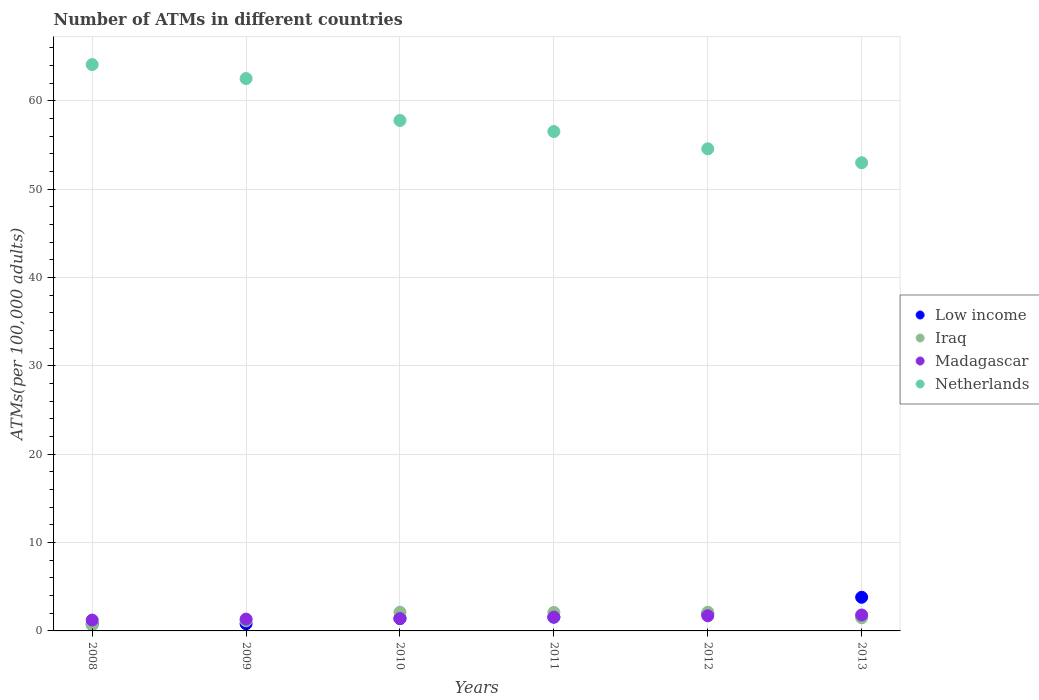Is the number of dotlines equal to the number of legend labels?
Provide a succinct answer. Yes. What is the number of ATMs in Iraq in 2011?
Offer a terse response. 2.09. Across all years, what is the maximum number of ATMs in Iraq?
Give a very brief answer. 2.12. Across all years, what is the minimum number of ATMs in Madagascar?
Your response must be concise. 1.23. In which year was the number of ATMs in Netherlands maximum?
Provide a short and direct response. 2008. In which year was the number of ATMs in Low income minimum?
Ensure brevity in your answer.  2008. What is the total number of ATMs in Iraq in the graph?
Ensure brevity in your answer.  9.63. What is the difference between the number of ATMs in Madagascar in 2010 and that in 2012?
Provide a succinct answer. -0.31. What is the difference between the number of ATMs in Low income in 2013 and the number of ATMs in Netherlands in 2009?
Your answer should be compact. -58.71. What is the average number of ATMs in Netherlands per year?
Offer a terse response. 58.08. In the year 2008, what is the difference between the number of ATMs in Madagascar and number of ATMs in Iraq?
Make the answer very short. 0.56. What is the ratio of the number of ATMs in Madagascar in 2010 to that in 2011?
Keep it short and to the point. 0.9. Is the number of ATMs in Netherlands in 2008 less than that in 2011?
Your answer should be very brief. No. Is the difference between the number of ATMs in Madagascar in 2011 and 2012 greater than the difference between the number of ATMs in Iraq in 2011 and 2012?
Make the answer very short. No. What is the difference between the highest and the second highest number of ATMs in Madagascar?
Offer a terse response. 0.09. What is the difference between the highest and the lowest number of ATMs in Madagascar?
Provide a succinct answer. 0.57. In how many years, is the number of ATMs in Netherlands greater than the average number of ATMs in Netherlands taken over all years?
Your answer should be compact. 2. Is the sum of the number of ATMs in Iraq in 2008 and 2012 greater than the maximum number of ATMs in Low income across all years?
Provide a short and direct response. No. Is it the case that in every year, the sum of the number of ATMs in Iraq and number of ATMs in Low income  is greater than the sum of number of ATMs in Madagascar and number of ATMs in Netherlands?
Your response must be concise. No. Does the number of ATMs in Netherlands monotonically increase over the years?
Offer a terse response. No. Is the number of ATMs in Madagascar strictly less than the number of ATMs in Netherlands over the years?
Make the answer very short. Yes. What is the difference between two consecutive major ticks on the Y-axis?
Your answer should be compact. 10. Does the graph contain grids?
Your answer should be compact. Yes. Where does the legend appear in the graph?
Give a very brief answer. Center right. What is the title of the graph?
Keep it short and to the point. Number of ATMs in different countries. What is the label or title of the Y-axis?
Provide a succinct answer. ATMs(per 100,0 adults). What is the ATMs(per 100,000 adults) of Low income in 2008?
Provide a short and direct response. 0.78. What is the ATMs(per 100,000 adults) of Iraq in 2008?
Keep it short and to the point. 0.67. What is the ATMs(per 100,000 adults) in Madagascar in 2008?
Provide a short and direct response. 1.23. What is the ATMs(per 100,000 adults) in Netherlands in 2008?
Your answer should be compact. 64.1. What is the ATMs(per 100,000 adults) of Low income in 2009?
Your response must be concise. 0.81. What is the ATMs(per 100,000 adults) of Iraq in 2009?
Your response must be concise. 1.15. What is the ATMs(per 100,000 adults) of Madagascar in 2009?
Offer a very short reply. 1.34. What is the ATMs(per 100,000 adults) of Netherlands in 2009?
Keep it short and to the point. 62.52. What is the ATMs(per 100,000 adults) of Low income in 2010?
Your answer should be compact. 1.4. What is the ATMs(per 100,000 adults) in Iraq in 2010?
Give a very brief answer. 2.12. What is the ATMs(per 100,000 adults) in Madagascar in 2010?
Provide a short and direct response. 1.4. What is the ATMs(per 100,000 adults) in Netherlands in 2010?
Offer a very short reply. 57.77. What is the ATMs(per 100,000 adults) in Low income in 2011?
Your answer should be compact. 1.56. What is the ATMs(per 100,000 adults) of Iraq in 2011?
Make the answer very short. 2.09. What is the ATMs(per 100,000 adults) of Madagascar in 2011?
Ensure brevity in your answer.  1.56. What is the ATMs(per 100,000 adults) in Netherlands in 2011?
Offer a very short reply. 56.52. What is the ATMs(per 100,000 adults) in Low income in 2012?
Give a very brief answer. 1.95. What is the ATMs(per 100,000 adults) of Iraq in 2012?
Keep it short and to the point. 2.12. What is the ATMs(per 100,000 adults) of Madagascar in 2012?
Ensure brevity in your answer.  1.71. What is the ATMs(per 100,000 adults) in Netherlands in 2012?
Your response must be concise. 54.56. What is the ATMs(per 100,000 adults) in Low income in 2013?
Make the answer very short. 3.81. What is the ATMs(per 100,000 adults) of Iraq in 2013?
Provide a short and direct response. 1.49. What is the ATMs(per 100,000 adults) of Madagascar in 2013?
Give a very brief answer. 1.8. What is the ATMs(per 100,000 adults) of Netherlands in 2013?
Give a very brief answer. 52.99. Across all years, what is the maximum ATMs(per 100,000 adults) of Low income?
Make the answer very short. 3.81. Across all years, what is the maximum ATMs(per 100,000 adults) in Iraq?
Keep it short and to the point. 2.12. Across all years, what is the maximum ATMs(per 100,000 adults) of Madagascar?
Your answer should be very brief. 1.8. Across all years, what is the maximum ATMs(per 100,000 adults) of Netherlands?
Your answer should be compact. 64.1. Across all years, what is the minimum ATMs(per 100,000 adults) of Low income?
Offer a terse response. 0.78. Across all years, what is the minimum ATMs(per 100,000 adults) of Iraq?
Offer a terse response. 0.67. Across all years, what is the minimum ATMs(per 100,000 adults) of Madagascar?
Provide a short and direct response. 1.23. Across all years, what is the minimum ATMs(per 100,000 adults) in Netherlands?
Keep it short and to the point. 52.99. What is the total ATMs(per 100,000 adults) in Low income in the graph?
Offer a very short reply. 10.32. What is the total ATMs(per 100,000 adults) in Iraq in the graph?
Your answer should be very brief. 9.63. What is the total ATMs(per 100,000 adults) in Madagascar in the graph?
Your answer should be compact. 9.04. What is the total ATMs(per 100,000 adults) in Netherlands in the graph?
Make the answer very short. 348.46. What is the difference between the ATMs(per 100,000 adults) in Low income in 2008 and that in 2009?
Provide a succinct answer. -0.03. What is the difference between the ATMs(per 100,000 adults) in Iraq in 2008 and that in 2009?
Your answer should be compact. -0.48. What is the difference between the ATMs(per 100,000 adults) in Madagascar in 2008 and that in 2009?
Your response must be concise. -0.11. What is the difference between the ATMs(per 100,000 adults) in Netherlands in 2008 and that in 2009?
Provide a succinct answer. 1.58. What is the difference between the ATMs(per 100,000 adults) in Low income in 2008 and that in 2010?
Your answer should be very brief. -0.62. What is the difference between the ATMs(per 100,000 adults) in Iraq in 2008 and that in 2010?
Give a very brief answer. -1.45. What is the difference between the ATMs(per 100,000 adults) of Madagascar in 2008 and that in 2010?
Your response must be concise. -0.17. What is the difference between the ATMs(per 100,000 adults) of Netherlands in 2008 and that in 2010?
Your answer should be compact. 6.32. What is the difference between the ATMs(per 100,000 adults) in Low income in 2008 and that in 2011?
Your answer should be very brief. -0.78. What is the difference between the ATMs(per 100,000 adults) in Iraq in 2008 and that in 2011?
Your answer should be compact. -1.42. What is the difference between the ATMs(per 100,000 adults) of Madagascar in 2008 and that in 2011?
Your answer should be compact. -0.34. What is the difference between the ATMs(per 100,000 adults) of Netherlands in 2008 and that in 2011?
Your answer should be compact. 7.57. What is the difference between the ATMs(per 100,000 adults) in Low income in 2008 and that in 2012?
Offer a very short reply. -1.17. What is the difference between the ATMs(per 100,000 adults) of Iraq in 2008 and that in 2012?
Your answer should be compact. -1.45. What is the difference between the ATMs(per 100,000 adults) of Madagascar in 2008 and that in 2012?
Your answer should be very brief. -0.49. What is the difference between the ATMs(per 100,000 adults) in Netherlands in 2008 and that in 2012?
Give a very brief answer. 9.53. What is the difference between the ATMs(per 100,000 adults) in Low income in 2008 and that in 2013?
Your response must be concise. -3.03. What is the difference between the ATMs(per 100,000 adults) of Iraq in 2008 and that in 2013?
Your answer should be very brief. -0.82. What is the difference between the ATMs(per 100,000 adults) in Madagascar in 2008 and that in 2013?
Your answer should be very brief. -0.57. What is the difference between the ATMs(per 100,000 adults) of Netherlands in 2008 and that in 2013?
Your answer should be compact. 11.11. What is the difference between the ATMs(per 100,000 adults) of Low income in 2009 and that in 2010?
Offer a terse response. -0.59. What is the difference between the ATMs(per 100,000 adults) in Iraq in 2009 and that in 2010?
Offer a very short reply. -0.97. What is the difference between the ATMs(per 100,000 adults) in Madagascar in 2009 and that in 2010?
Provide a short and direct response. -0.06. What is the difference between the ATMs(per 100,000 adults) in Netherlands in 2009 and that in 2010?
Your response must be concise. 4.74. What is the difference between the ATMs(per 100,000 adults) in Low income in 2009 and that in 2011?
Make the answer very short. -0.75. What is the difference between the ATMs(per 100,000 adults) of Iraq in 2009 and that in 2011?
Offer a terse response. -0.94. What is the difference between the ATMs(per 100,000 adults) in Madagascar in 2009 and that in 2011?
Provide a succinct answer. -0.23. What is the difference between the ATMs(per 100,000 adults) of Netherlands in 2009 and that in 2011?
Provide a short and direct response. 5.99. What is the difference between the ATMs(per 100,000 adults) of Low income in 2009 and that in 2012?
Provide a short and direct response. -1.14. What is the difference between the ATMs(per 100,000 adults) in Iraq in 2009 and that in 2012?
Keep it short and to the point. -0.97. What is the difference between the ATMs(per 100,000 adults) in Madagascar in 2009 and that in 2012?
Offer a very short reply. -0.38. What is the difference between the ATMs(per 100,000 adults) in Netherlands in 2009 and that in 2012?
Ensure brevity in your answer.  7.95. What is the difference between the ATMs(per 100,000 adults) in Low income in 2009 and that in 2013?
Provide a succinct answer. -3. What is the difference between the ATMs(per 100,000 adults) in Iraq in 2009 and that in 2013?
Offer a terse response. -0.34. What is the difference between the ATMs(per 100,000 adults) in Madagascar in 2009 and that in 2013?
Provide a succinct answer. -0.47. What is the difference between the ATMs(per 100,000 adults) in Netherlands in 2009 and that in 2013?
Make the answer very short. 9.53. What is the difference between the ATMs(per 100,000 adults) of Low income in 2010 and that in 2011?
Keep it short and to the point. -0.16. What is the difference between the ATMs(per 100,000 adults) of Iraq in 2010 and that in 2011?
Your response must be concise. 0.03. What is the difference between the ATMs(per 100,000 adults) in Madagascar in 2010 and that in 2011?
Offer a very short reply. -0.16. What is the difference between the ATMs(per 100,000 adults) of Netherlands in 2010 and that in 2011?
Make the answer very short. 1.25. What is the difference between the ATMs(per 100,000 adults) of Low income in 2010 and that in 2012?
Provide a short and direct response. -0.55. What is the difference between the ATMs(per 100,000 adults) in Iraq in 2010 and that in 2012?
Make the answer very short. 0. What is the difference between the ATMs(per 100,000 adults) in Madagascar in 2010 and that in 2012?
Ensure brevity in your answer.  -0.31. What is the difference between the ATMs(per 100,000 adults) in Netherlands in 2010 and that in 2012?
Provide a succinct answer. 3.21. What is the difference between the ATMs(per 100,000 adults) of Low income in 2010 and that in 2013?
Your answer should be very brief. -2.41. What is the difference between the ATMs(per 100,000 adults) of Iraq in 2010 and that in 2013?
Provide a succinct answer. 0.63. What is the difference between the ATMs(per 100,000 adults) in Madagascar in 2010 and that in 2013?
Offer a very short reply. -0.4. What is the difference between the ATMs(per 100,000 adults) of Netherlands in 2010 and that in 2013?
Make the answer very short. 4.78. What is the difference between the ATMs(per 100,000 adults) of Low income in 2011 and that in 2012?
Keep it short and to the point. -0.39. What is the difference between the ATMs(per 100,000 adults) in Iraq in 2011 and that in 2012?
Make the answer very short. -0.03. What is the difference between the ATMs(per 100,000 adults) in Madagascar in 2011 and that in 2012?
Your answer should be compact. -0.15. What is the difference between the ATMs(per 100,000 adults) of Netherlands in 2011 and that in 2012?
Offer a very short reply. 1.96. What is the difference between the ATMs(per 100,000 adults) in Low income in 2011 and that in 2013?
Make the answer very short. -2.25. What is the difference between the ATMs(per 100,000 adults) of Iraq in 2011 and that in 2013?
Provide a succinct answer. 0.6. What is the difference between the ATMs(per 100,000 adults) of Madagascar in 2011 and that in 2013?
Offer a very short reply. -0.24. What is the difference between the ATMs(per 100,000 adults) of Netherlands in 2011 and that in 2013?
Offer a very short reply. 3.53. What is the difference between the ATMs(per 100,000 adults) of Low income in 2012 and that in 2013?
Provide a short and direct response. -1.85. What is the difference between the ATMs(per 100,000 adults) in Iraq in 2012 and that in 2013?
Provide a short and direct response. 0.63. What is the difference between the ATMs(per 100,000 adults) of Madagascar in 2012 and that in 2013?
Provide a short and direct response. -0.09. What is the difference between the ATMs(per 100,000 adults) in Netherlands in 2012 and that in 2013?
Make the answer very short. 1.58. What is the difference between the ATMs(per 100,000 adults) in Low income in 2008 and the ATMs(per 100,000 adults) in Iraq in 2009?
Give a very brief answer. -0.37. What is the difference between the ATMs(per 100,000 adults) of Low income in 2008 and the ATMs(per 100,000 adults) of Madagascar in 2009?
Offer a terse response. -0.55. What is the difference between the ATMs(per 100,000 adults) of Low income in 2008 and the ATMs(per 100,000 adults) of Netherlands in 2009?
Your response must be concise. -61.73. What is the difference between the ATMs(per 100,000 adults) of Iraq in 2008 and the ATMs(per 100,000 adults) of Madagascar in 2009?
Make the answer very short. -0.67. What is the difference between the ATMs(per 100,000 adults) in Iraq in 2008 and the ATMs(per 100,000 adults) in Netherlands in 2009?
Offer a terse response. -61.85. What is the difference between the ATMs(per 100,000 adults) of Madagascar in 2008 and the ATMs(per 100,000 adults) of Netherlands in 2009?
Provide a succinct answer. -61.29. What is the difference between the ATMs(per 100,000 adults) in Low income in 2008 and the ATMs(per 100,000 adults) in Iraq in 2010?
Offer a very short reply. -1.33. What is the difference between the ATMs(per 100,000 adults) of Low income in 2008 and the ATMs(per 100,000 adults) of Madagascar in 2010?
Ensure brevity in your answer.  -0.62. What is the difference between the ATMs(per 100,000 adults) in Low income in 2008 and the ATMs(per 100,000 adults) in Netherlands in 2010?
Provide a succinct answer. -56.99. What is the difference between the ATMs(per 100,000 adults) of Iraq in 2008 and the ATMs(per 100,000 adults) of Madagascar in 2010?
Your answer should be very brief. -0.73. What is the difference between the ATMs(per 100,000 adults) of Iraq in 2008 and the ATMs(per 100,000 adults) of Netherlands in 2010?
Keep it short and to the point. -57.1. What is the difference between the ATMs(per 100,000 adults) in Madagascar in 2008 and the ATMs(per 100,000 adults) in Netherlands in 2010?
Give a very brief answer. -56.54. What is the difference between the ATMs(per 100,000 adults) of Low income in 2008 and the ATMs(per 100,000 adults) of Iraq in 2011?
Provide a short and direct response. -1.31. What is the difference between the ATMs(per 100,000 adults) of Low income in 2008 and the ATMs(per 100,000 adults) of Madagascar in 2011?
Make the answer very short. -0.78. What is the difference between the ATMs(per 100,000 adults) of Low income in 2008 and the ATMs(per 100,000 adults) of Netherlands in 2011?
Your response must be concise. -55.74. What is the difference between the ATMs(per 100,000 adults) of Iraq in 2008 and the ATMs(per 100,000 adults) of Madagascar in 2011?
Ensure brevity in your answer.  -0.89. What is the difference between the ATMs(per 100,000 adults) in Iraq in 2008 and the ATMs(per 100,000 adults) in Netherlands in 2011?
Make the answer very short. -55.85. What is the difference between the ATMs(per 100,000 adults) in Madagascar in 2008 and the ATMs(per 100,000 adults) in Netherlands in 2011?
Offer a terse response. -55.29. What is the difference between the ATMs(per 100,000 adults) in Low income in 2008 and the ATMs(per 100,000 adults) in Iraq in 2012?
Give a very brief answer. -1.33. What is the difference between the ATMs(per 100,000 adults) of Low income in 2008 and the ATMs(per 100,000 adults) of Madagascar in 2012?
Ensure brevity in your answer.  -0.93. What is the difference between the ATMs(per 100,000 adults) in Low income in 2008 and the ATMs(per 100,000 adults) in Netherlands in 2012?
Your response must be concise. -53.78. What is the difference between the ATMs(per 100,000 adults) in Iraq in 2008 and the ATMs(per 100,000 adults) in Madagascar in 2012?
Offer a terse response. -1.05. What is the difference between the ATMs(per 100,000 adults) in Iraq in 2008 and the ATMs(per 100,000 adults) in Netherlands in 2012?
Your response must be concise. -53.89. What is the difference between the ATMs(per 100,000 adults) in Madagascar in 2008 and the ATMs(per 100,000 adults) in Netherlands in 2012?
Offer a very short reply. -53.34. What is the difference between the ATMs(per 100,000 adults) of Low income in 2008 and the ATMs(per 100,000 adults) of Iraq in 2013?
Provide a succinct answer. -0.71. What is the difference between the ATMs(per 100,000 adults) in Low income in 2008 and the ATMs(per 100,000 adults) in Madagascar in 2013?
Offer a terse response. -1.02. What is the difference between the ATMs(per 100,000 adults) in Low income in 2008 and the ATMs(per 100,000 adults) in Netherlands in 2013?
Offer a very short reply. -52.21. What is the difference between the ATMs(per 100,000 adults) of Iraq in 2008 and the ATMs(per 100,000 adults) of Madagascar in 2013?
Your response must be concise. -1.13. What is the difference between the ATMs(per 100,000 adults) of Iraq in 2008 and the ATMs(per 100,000 adults) of Netherlands in 2013?
Keep it short and to the point. -52.32. What is the difference between the ATMs(per 100,000 adults) in Madagascar in 2008 and the ATMs(per 100,000 adults) in Netherlands in 2013?
Provide a succinct answer. -51.76. What is the difference between the ATMs(per 100,000 adults) in Low income in 2009 and the ATMs(per 100,000 adults) in Iraq in 2010?
Offer a terse response. -1.31. What is the difference between the ATMs(per 100,000 adults) of Low income in 2009 and the ATMs(per 100,000 adults) of Madagascar in 2010?
Your answer should be compact. -0.59. What is the difference between the ATMs(per 100,000 adults) of Low income in 2009 and the ATMs(per 100,000 adults) of Netherlands in 2010?
Offer a terse response. -56.96. What is the difference between the ATMs(per 100,000 adults) of Iraq in 2009 and the ATMs(per 100,000 adults) of Madagascar in 2010?
Your answer should be very brief. -0.25. What is the difference between the ATMs(per 100,000 adults) in Iraq in 2009 and the ATMs(per 100,000 adults) in Netherlands in 2010?
Give a very brief answer. -56.62. What is the difference between the ATMs(per 100,000 adults) of Madagascar in 2009 and the ATMs(per 100,000 adults) of Netherlands in 2010?
Provide a succinct answer. -56.44. What is the difference between the ATMs(per 100,000 adults) of Low income in 2009 and the ATMs(per 100,000 adults) of Iraq in 2011?
Give a very brief answer. -1.28. What is the difference between the ATMs(per 100,000 adults) in Low income in 2009 and the ATMs(per 100,000 adults) in Madagascar in 2011?
Offer a very short reply. -0.75. What is the difference between the ATMs(per 100,000 adults) of Low income in 2009 and the ATMs(per 100,000 adults) of Netherlands in 2011?
Offer a terse response. -55.71. What is the difference between the ATMs(per 100,000 adults) in Iraq in 2009 and the ATMs(per 100,000 adults) in Madagascar in 2011?
Provide a succinct answer. -0.41. What is the difference between the ATMs(per 100,000 adults) in Iraq in 2009 and the ATMs(per 100,000 adults) in Netherlands in 2011?
Offer a very short reply. -55.37. What is the difference between the ATMs(per 100,000 adults) in Madagascar in 2009 and the ATMs(per 100,000 adults) in Netherlands in 2011?
Offer a very short reply. -55.19. What is the difference between the ATMs(per 100,000 adults) in Low income in 2009 and the ATMs(per 100,000 adults) in Iraq in 2012?
Provide a succinct answer. -1.31. What is the difference between the ATMs(per 100,000 adults) of Low income in 2009 and the ATMs(per 100,000 adults) of Madagascar in 2012?
Offer a terse response. -0.91. What is the difference between the ATMs(per 100,000 adults) of Low income in 2009 and the ATMs(per 100,000 adults) of Netherlands in 2012?
Your answer should be compact. -53.75. What is the difference between the ATMs(per 100,000 adults) of Iraq in 2009 and the ATMs(per 100,000 adults) of Madagascar in 2012?
Your response must be concise. -0.56. What is the difference between the ATMs(per 100,000 adults) of Iraq in 2009 and the ATMs(per 100,000 adults) of Netherlands in 2012?
Provide a succinct answer. -53.41. What is the difference between the ATMs(per 100,000 adults) of Madagascar in 2009 and the ATMs(per 100,000 adults) of Netherlands in 2012?
Make the answer very short. -53.23. What is the difference between the ATMs(per 100,000 adults) of Low income in 2009 and the ATMs(per 100,000 adults) of Iraq in 2013?
Provide a short and direct response. -0.68. What is the difference between the ATMs(per 100,000 adults) in Low income in 2009 and the ATMs(per 100,000 adults) in Madagascar in 2013?
Your answer should be compact. -0.99. What is the difference between the ATMs(per 100,000 adults) of Low income in 2009 and the ATMs(per 100,000 adults) of Netherlands in 2013?
Offer a very short reply. -52.18. What is the difference between the ATMs(per 100,000 adults) of Iraq in 2009 and the ATMs(per 100,000 adults) of Madagascar in 2013?
Provide a succinct answer. -0.65. What is the difference between the ATMs(per 100,000 adults) of Iraq in 2009 and the ATMs(per 100,000 adults) of Netherlands in 2013?
Provide a short and direct response. -51.84. What is the difference between the ATMs(per 100,000 adults) of Madagascar in 2009 and the ATMs(per 100,000 adults) of Netherlands in 2013?
Offer a very short reply. -51.65. What is the difference between the ATMs(per 100,000 adults) of Low income in 2010 and the ATMs(per 100,000 adults) of Iraq in 2011?
Make the answer very short. -0.69. What is the difference between the ATMs(per 100,000 adults) of Low income in 2010 and the ATMs(per 100,000 adults) of Madagascar in 2011?
Provide a succinct answer. -0.16. What is the difference between the ATMs(per 100,000 adults) of Low income in 2010 and the ATMs(per 100,000 adults) of Netherlands in 2011?
Give a very brief answer. -55.12. What is the difference between the ATMs(per 100,000 adults) of Iraq in 2010 and the ATMs(per 100,000 adults) of Madagascar in 2011?
Your response must be concise. 0.55. What is the difference between the ATMs(per 100,000 adults) in Iraq in 2010 and the ATMs(per 100,000 adults) in Netherlands in 2011?
Make the answer very short. -54.41. What is the difference between the ATMs(per 100,000 adults) of Madagascar in 2010 and the ATMs(per 100,000 adults) of Netherlands in 2011?
Offer a terse response. -55.12. What is the difference between the ATMs(per 100,000 adults) of Low income in 2010 and the ATMs(per 100,000 adults) of Iraq in 2012?
Provide a short and direct response. -0.71. What is the difference between the ATMs(per 100,000 adults) of Low income in 2010 and the ATMs(per 100,000 adults) of Madagascar in 2012?
Keep it short and to the point. -0.31. What is the difference between the ATMs(per 100,000 adults) of Low income in 2010 and the ATMs(per 100,000 adults) of Netherlands in 2012?
Your response must be concise. -53.16. What is the difference between the ATMs(per 100,000 adults) in Iraq in 2010 and the ATMs(per 100,000 adults) in Madagascar in 2012?
Your answer should be compact. 0.4. What is the difference between the ATMs(per 100,000 adults) in Iraq in 2010 and the ATMs(per 100,000 adults) in Netherlands in 2012?
Ensure brevity in your answer.  -52.45. What is the difference between the ATMs(per 100,000 adults) of Madagascar in 2010 and the ATMs(per 100,000 adults) of Netherlands in 2012?
Make the answer very short. -53.16. What is the difference between the ATMs(per 100,000 adults) of Low income in 2010 and the ATMs(per 100,000 adults) of Iraq in 2013?
Your answer should be compact. -0.09. What is the difference between the ATMs(per 100,000 adults) of Low income in 2010 and the ATMs(per 100,000 adults) of Madagascar in 2013?
Provide a short and direct response. -0.4. What is the difference between the ATMs(per 100,000 adults) of Low income in 2010 and the ATMs(per 100,000 adults) of Netherlands in 2013?
Make the answer very short. -51.59. What is the difference between the ATMs(per 100,000 adults) of Iraq in 2010 and the ATMs(per 100,000 adults) of Madagascar in 2013?
Your response must be concise. 0.31. What is the difference between the ATMs(per 100,000 adults) in Iraq in 2010 and the ATMs(per 100,000 adults) in Netherlands in 2013?
Provide a succinct answer. -50.87. What is the difference between the ATMs(per 100,000 adults) of Madagascar in 2010 and the ATMs(per 100,000 adults) of Netherlands in 2013?
Your response must be concise. -51.59. What is the difference between the ATMs(per 100,000 adults) of Low income in 2011 and the ATMs(per 100,000 adults) of Iraq in 2012?
Give a very brief answer. -0.55. What is the difference between the ATMs(per 100,000 adults) in Low income in 2011 and the ATMs(per 100,000 adults) in Madagascar in 2012?
Your answer should be compact. -0.15. What is the difference between the ATMs(per 100,000 adults) in Low income in 2011 and the ATMs(per 100,000 adults) in Netherlands in 2012?
Provide a succinct answer. -53. What is the difference between the ATMs(per 100,000 adults) of Iraq in 2011 and the ATMs(per 100,000 adults) of Madagascar in 2012?
Your answer should be compact. 0.37. What is the difference between the ATMs(per 100,000 adults) in Iraq in 2011 and the ATMs(per 100,000 adults) in Netherlands in 2012?
Make the answer very short. -52.48. What is the difference between the ATMs(per 100,000 adults) of Madagascar in 2011 and the ATMs(per 100,000 adults) of Netherlands in 2012?
Provide a succinct answer. -53. What is the difference between the ATMs(per 100,000 adults) of Low income in 2011 and the ATMs(per 100,000 adults) of Iraq in 2013?
Offer a very short reply. 0.08. What is the difference between the ATMs(per 100,000 adults) in Low income in 2011 and the ATMs(per 100,000 adults) in Madagascar in 2013?
Provide a short and direct response. -0.24. What is the difference between the ATMs(per 100,000 adults) of Low income in 2011 and the ATMs(per 100,000 adults) of Netherlands in 2013?
Provide a short and direct response. -51.42. What is the difference between the ATMs(per 100,000 adults) of Iraq in 2011 and the ATMs(per 100,000 adults) of Madagascar in 2013?
Your response must be concise. 0.29. What is the difference between the ATMs(per 100,000 adults) in Iraq in 2011 and the ATMs(per 100,000 adults) in Netherlands in 2013?
Your answer should be compact. -50.9. What is the difference between the ATMs(per 100,000 adults) of Madagascar in 2011 and the ATMs(per 100,000 adults) of Netherlands in 2013?
Make the answer very short. -51.42. What is the difference between the ATMs(per 100,000 adults) in Low income in 2012 and the ATMs(per 100,000 adults) in Iraq in 2013?
Make the answer very short. 0.47. What is the difference between the ATMs(per 100,000 adults) of Low income in 2012 and the ATMs(per 100,000 adults) of Madagascar in 2013?
Ensure brevity in your answer.  0.15. What is the difference between the ATMs(per 100,000 adults) in Low income in 2012 and the ATMs(per 100,000 adults) in Netherlands in 2013?
Offer a very short reply. -51.03. What is the difference between the ATMs(per 100,000 adults) in Iraq in 2012 and the ATMs(per 100,000 adults) in Madagascar in 2013?
Offer a very short reply. 0.31. What is the difference between the ATMs(per 100,000 adults) of Iraq in 2012 and the ATMs(per 100,000 adults) of Netherlands in 2013?
Keep it short and to the point. -50.87. What is the difference between the ATMs(per 100,000 adults) of Madagascar in 2012 and the ATMs(per 100,000 adults) of Netherlands in 2013?
Give a very brief answer. -51.27. What is the average ATMs(per 100,000 adults) of Low income per year?
Make the answer very short. 1.72. What is the average ATMs(per 100,000 adults) of Iraq per year?
Provide a succinct answer. 1.6. What is the average ATMs(per 100,000 adults) in Madagascar per year?
Provide a short and direct response. 1.51. What is the average ATMs(per 100,000 adults) in Netherlands per year?
Provide a succinct answer. 58.08. In the year 2008, what is the difference between the ATMs(per 100,000 adults) of Low income and ATMs(per 100,000 adults) of Iraq?
Your answer should be compact. 0.11. In the year 2008, what is the difference between the ATMs(per 100,000 adults) of Low income and ATMs(per 100,000 adults) of Madagascar?
Your answer should be very brief. -0.45. In the year 2008, what is the difference between the ATMs(per 100,000 adults) of Low income and ATMs(per 100,000 adults) of Netherlands?
Your response must be concise. -63.31. In the year 2008, what is the difference between the ATMs(per 100,000 adults) of Iraq and ATMs(per 100,000 adults) of Madagascar?
Give a very brief answer. -0.56. In the year 2008, what is the difference between the ATMs(per 100,000 adults) of Iraq and ATMs(per 100,000 adults) of Netherlands?
Make the answer very short. -63.43. In the year 2008, what is the difference between the ATMs(per 100,000 adults) in Madagascar and ATMs(per 100,000 adults) in Netherlands?
Offer a very short reply. -62.87. In the year 2009, what is the difference between the ATMs(per 100,000 adults) of Low income and ATMs(per 100,000 adults) of Iraq?
Your response must be concise. -0.34. In the year 2009, what is the difference between the ATMs(per 100,000 adults) of Low income and ATMs(per 100,000 adults) of Madagascar?
Provide a succinct answer. -0.53. In the year 2009, what is the difference between the ATMs(per 100,000 adults) in Low income and ATMs(per 100,000 adults) in Netherlands?
Provide a short and direct response. -61.71. In the year 2009, what is the difference between the ATMs(per 100,000 adults) in Iraq and ATMs(per 100,000 adults) in Madagascar?
Provide a short and direct response. -0.19. In the year 2009, what is the difference between the ATMs(per 100,000 adults) of Iraq and ATMs(per 100,000 adults) of Netherlands?
Give a very brief answer. -61.37. In the year 2009, what is the difference between the ATMs(per 100,000 adults) in Madagascar and ATMs(per 100,000 adults) in Netherlands?
Ensure brevity in your answer.  -61.18. In the year 2010, what is the difference between the ATMs(per 100,000 adults) in Low income and ATMs(per 100,000 adults) in Iraq?
Ensure brevity in your answer.  -0.71. In the year 2010, what is the difference between the ATMs(per 100,000 adults) of Low income and ATMs(per 100,000 adults) of Madagascar?
Make the answer very short. 0. In the year 2010, what is the difference between the ATMs(per 100,000 adults) of Low income and ATMs(per 100,000 adults) of Netherlands?
Make the answer very short. -56.37. In the year 2010, what is the difference between the ATMs(per 100,000 adults) of Iraq and ATMs(per 100,000 adults) of Madagascar?
Ensure brevity in your answer.  0.72. In the year 2010, what is the difference between the ATMs(per 100,000 adults) in Iraq and ATMs(per 100,000 adults) in Netherlands?
Provide a succinct answer. -55.66. In the year 2010, what is the difference between the ATMs(per 100,000 adults) in Madagascar and ATMs(per 100,000 adults) in Netherlands?
Offer a very short reply. -56.37. In the year 2011, what is the difference between the ATMs(per 100,000 adults) in Low income and ATMs(per 100,000 adults) in Iraq?
Your answer should be very brief. -0.52. In the year 2011, what is the difference between the ATMs(per 100,000 adults) of Low income and ATMs(per 100,000 adults) of Netherlands?
Your answer should be very brief. -54.96. In the year 2011, what is the difference between the ATMs(per 100,000 adults) in Iraq and ATMs(per 100,000 adults) in Madagascar?
Your answer should be very brief. 0.52. In the year 2011, what is the difference between the ATMs(per 100,000 adults) of Iraq and ATMs(per 100,000 adults) of Netherlands?
Keep it short and to the point. -54.43. In the year 2011, what is the difference between the ATMs(per 100,000 adults) in Madagascar and ATMs(per 100,000 adults) in Netherlands?
Your answer should be very brief. -54.96. In the year 2012, what is the difference between the ATMs(per 100,000 adults) of Low income and ATMs(per 100,000 adults) of Iraq?
Your answer should be compact. -0.16. In the year 2012, what is the difference between the ATMs(per 100,000 adults) in Low income and ATMs(per 100,000 adults) in Madagascar?
Keep it short and to the point. 0.24. In the year 2012, what is the difference between the ATMs(per 100,000 adults) of Low income and ATMs(per 100,000 adults) of Netherlands?
Keep it short and to the point. -52.61. In the year 2012, what is the difference between the ATMs(per 100,000 adults) in Iraq and ATMs(per 100,000 adults) in Madagascar?
Offer a very short reply. 0.4. In the year 2012, what is the difference between the ATMs(per 100,000 adults) of Iraq and ATMs(per 100,000 adults) of Netherlands?
Your response must be concise. -52.45. In the year 2012, what is the difference between the ATMs(per 100,000 adults) of Madagascar and ATMs(per 100,000 adults) of Netherlands?
Offer a very short reply. -52.85. In the year 2013, what is the difference between the ATMs(per 100,000 adults) of Low income and ATMs(per 100,000 adults) of Iraq?
Provide a succinct answer. 2.32. In the year 2013, what is the difference between the ATMs(per 100,000 adults) in Low income and ATMs(per 100,000 adults) in Madagascar?
Your answer should be compact. 2.01. In the year 2013, what is the difference between the ATMs(per 100,000 adults) in Low income and ATMs(per 100,000 adults) in Netherlands?
Your response must be concise. -49.18. In the year 2013, what is the difference between the ATMs(per 100,000 adults) in Iraq and ATMs(per 100,000 adults) in Madagascar?
Provide a succinct answer. -0.31. In the year 2013, what is the difference between the ATMs(per 100,000 adults) of Iraq and ATMs(per 100,000 adults) of Netherlands?
Offer a very short reply. -51.5. In the year 2013, what is the difference between the ATMs(per 100,000 adults) in Madagascar and ATMs(per 100,000 adults) in Netherlands?
Your answer should be compact. -51.19. What is the ratio of the ATMs(per 100,000 adults) in Low income in 2008 to that in 2009?
Your answer should be compact. 0.97. What is the ratio of the ATMs(per 100,000 adults) of Iraq in 2008 to that in 2009?
Your answer should be compact. 0.58. What is the ratio of the ATMs(per 100,000 adults) in Netherlands in 2008 to that in 2009?
Provide a short and direct response. 1.03. What is the ratio of the ATMs(per 100,000 adults) of Low income in 2008 to that in 2010?
Give a very brief answer. 0.56. What is the ratio of the ATMs(per 100,000 adults) of Iraq in 2008 to that in 2010?
Make the answer very short. 0.32. What is the ratio of the ATMs(per 100,000 adults) in Madagascar in 2008 to that in 2010?
Provide a succinct answer. 0.88. What is the ratio of the ATMs(per 100,000 adults) in Netherlands in 2008 to that in 2010?
Your answer should be very brief. 1.11. What is the ratio of the ATMs(per 100,000 adults) in Low income in 2008 to that in 2011?
Your answer should be very brief. 0.5. What is the ratio of the ATMs(per 100,000 adults) of Iraq in 2008 to that in 2011?
Provide a succinct answer. 0.32. What is the ratio of the ATMs(per 100,000 adults) of Madagascar in 2008 to that in 2011?
Your answer should be compact. 0.79. What is the ratio of the ATMs(per 100,000 adults) of Netherlands in 2008 to that in 2011?
Make the answer very short. 1.13. What is the ratio of the ATMs(per 100,000 adults) in Low income in 2008 to that in 2012?
Make the answer very short. 0.4. What is the ratio of the ATMs(per 100,000 adults) of Iraq in 2008 to that in 2012?
Give a very brief answer. 0.32. What is the ratio of the ATMs(per 100,000 adults) of Madagascar in 2008 to that in 2012?
Your answer should be very brief. 0.72. What is the ratio of the ATMs(per 100,000 adults) in Netherlands in 2008 to that in 2012?
Provide a short and direct response. 1.17. What is the ratio of the ATMs(per 100,000 adults) of Low income in 2008 to that in 2013?
Ensure brevity in your answer.  0.21. What is the ratio of the ATMs(per 100,000 adults) in Iraq in 2008 to that in 2013?
Your response must be concise. 0.45. What is the ratio of the ATMs(per 100,000 adults) of Madagascar in 2008 to that in 2013?
Provide a short and direct response. 0.68. What is the ratio of the ATMs(per 100,000 adults) of Netherlands in 2008 to that in 2013?
Your response must be concise. 1.21. What is the ratio of the ATMs(per 100,000 adults) in Low income in 2009 to that in 2010?
Give a very brief answer. 0.58. What is the ratio of the ATMs(per 100,000 adults) in Iraq in 2009 to that in 2010?
Make the answer very short. 0.54. What is the ratio of the ATMs(per 100,000 adults) in Madagascar in 2009 to that in 2010?
Make the answer very short. 0.95. What is the ratio of the ATMs(per 100,000 adults) of Netherlands in 2009 to that in 2010?
Make the answer very short. 1.08. What is the ratio of the ATMs(per 100,000 adults) in Low income in 2009 to that in 2011?
Provide a short and direct response. 0.52. What is the ratio of the ATMs(per 100,000 adults) in Iraq in 2009 to that in 2011?
Your response must be concise. 0.55. What is the ratio of the ATMs(per 100,000 adults) of Madagascar in 2009 to that in 2011?
Your answer should be compact. 0.85. What is the ratio of the ATMs(per 100,000 adults) in Netherlands in 2009 to that in 2011?
Provide a short and direct response. 1.11. What is the ratio of the ATMs(per 100,000 adults) of Low income in 2009 to that in 2012?
Offer a very short reply. 0.41. What is the ratio of the ATMs(per 100,000 adults) of Iraq in 2009 to that in 2012?
Offer a very short reply. 0.54. What is the ratio of the ATMs(per 100,000 adults) in Madagascar in 2009 to that in 2012?
Offer a very short reply. 0.78. What is the ratio of the ATMs(per 100,000 adults) in Netherlands in 2009 to that in 2012?
Provide a short and direct response. 1.15. What is the ratio of the ATMs(per 100,000 adults) in Low income in 2009 to that in 2013?
Give a very brief answer. 0.21. What is the ratio of the ATMs(per 100,000 adults) in Iraq in 2009 to that in 2013?
Your answer should be very brief. 0.77. What is the ratio of the ATMs(per 100,000 adults) in Madagascar in 2009 to that in 2013?
Provide a short and direct response. 0.74. What is the ratio of the ATMs(per 100,000 adults) of Netherlands in 2009 to that in 2013?
Make the answer very short. 1.18. What is the ratio of the ATMs(per 100,000 adults) of Low income in 2010 to that in 2011?
Keep it short and to the point. 0.9. What is the ratio of the ATMs(per 100,000 adults) in Iraq in 2010 to that in 2011?
Offer a very short reply. 1.01. What is the ratio of the ATMs(per 100,000 adults) of Madagascar in 2010 to that in 2011?
Give a very brief answer. 0.9. What is the ratio of the ATMs(per 100,000 adults) of Netherlands in 2010 to that in 2011?
Offer a terse response. 1.02. What is the ratio of the ATMs(per 100,000 adults) in Low income in 2010 to that in 2012?
Provide a succinct answer. 0.72. What is the ratio of the ATMs(per 100,000 adults) of Iraq in 2010 to that in 2012?
Ensure brevity in your answer.  1. What is the ratio of the ATMs(per 100,000 adults) of Madagascar in 2010 to that in 2012?
Provide a short and direct response. 0.82. What is the ratio of the ATMs(per 100,000 adults) in Netherlands in 2010 to that in 2012?
Offer a terse response. 1.06. What is the ratio of the ATMs(per 100,000 adults) in Low income in 2010 to that in 2013?
Provide a short and direct response. 0.37. What is the ratio of the ATMs(per 100,000 adults) of Iraq in 2010 to that in 2013?
Your response must be concise. 1.42. What is the ratio of the ATMs(per 100,000 adults) in Madagascar in 2010 to that in 2013?
Your answer should be compact. 0.78. What is the ratio of the ATMs(per 100,000 adults) of Netherlands in 2010 to that in 2013?
Give a very brief answer. 1.09. What is the ratio of the ATMs(per 100,000 adults) of Low income in 2011 to that in 2012?
Your answer should be very brief. 0.8. What is the ratio of the ATMs(per 100,000 adults) of Iraq in 2011 to that in 2012?
Provide a succinct answer. 0.99. What is the ratio of the ATMs(per 100,000 adults) in Madagascar in 2011 to that in 2012?
Offer a very short reply. 0.91. What is the ratio of the ATMs(per 100,000 adults) of Netherlands in 2011 to that in 2012?
Make the answer very short. 1.04. What is the ratio of the ATMs(per 100,000 adults) of Low income in 2011 to that in 2013?
Give a very brief answer. 0.41. What is the ratio of the ATMs(per 100,000 adults) in Iraq in 2011 to that in 2013?
Offer a very short reply. 1.4. What is the ratio of the ATMs(per 100,000 adults) of Madagascar in 2011 to that in 2013?
Ensure brevity in your answer.  0.87. What is the ratio of the ATMs(per 100,000 adults) of Netherlands in 2011 to that in 2013?
Offer a very short reply. 1.07. What is the ratio of the ATMs(per 100,000 adults) of Low income in 2012 to that in 2013?
Your answer should be compact. 0.51. What is the ratio of the ATMs(per 100,000 adults) in Iraq in 2012 to that in 2013?
Your answer should be compact. 1.42. What is the ratio of the ATMs(per 100,000 adults) of Madagascar in 2012 to that in 2013?
Your response must be concise. 0.95. What is the ratio of the ATMs(per 100,000 adults) in Netherlands in 2012 to that in 2013?
Keep it short and to the point. 1.03. What is the difference between the highest and the second highest ATMs(per 100,000 adults) in Low income?
Your answer should be compact. 1.85. What is the difference between the highest and the second highest ATMs(per 100,000 adults) of Iraq?
Ensure brevity in your answer.  0. What is the difference between the highest and the second highest ATMs(per 100,000 adults) in Madagascar?
Make the answer very short. 0.09. What is the difference between the highest and the second highest ATMs(per 100,000 adults) in Netherlands?
Make the answer very short. 1.58. What is the difference between the highest and the lowest ATMs(per 100,000 adults) of Low income?
Provide a succinct answer. 3.03. What is the difference between the highest and the lowest ATMs(per 100,000 adults) in Iraq?
Provide a short and direct response. 1.45. What is the difference between the highest and the lowest ATMs(per 100,000 adults) of Madagascar?
Offer a terse response. 0.57. What is the difference between the highest and the lowest ATMs(per 100,000 adults) in Netherlands?
Provide a short and direct response. 11.11. 